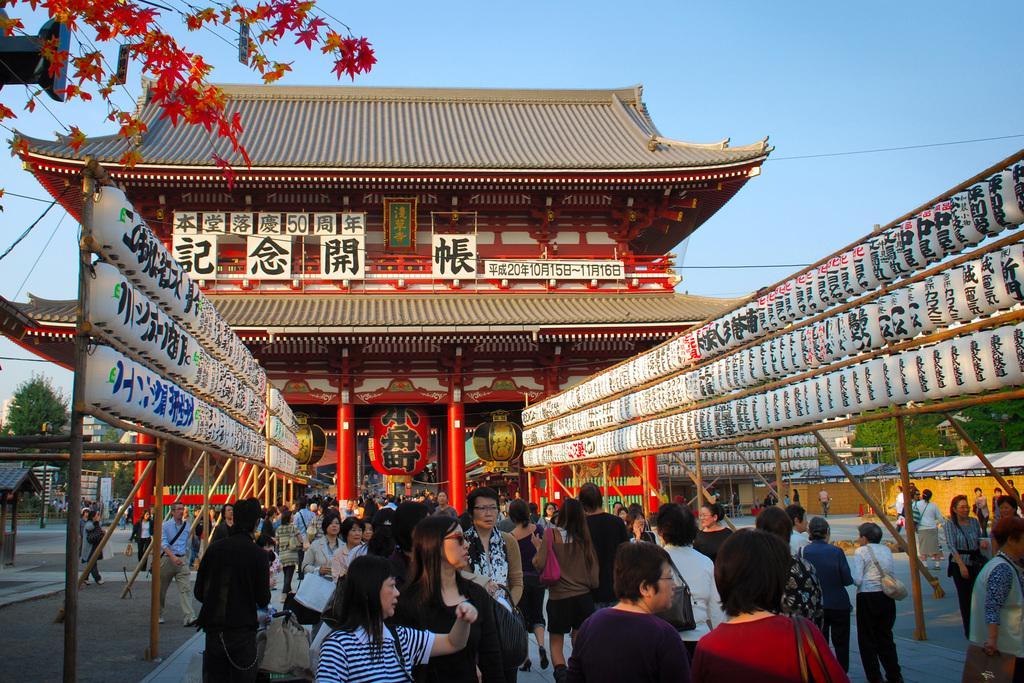In one or two sentences, can you explain what this image depicts? In this image we can see people walking. In the background of the image there is a house. There are trees. 